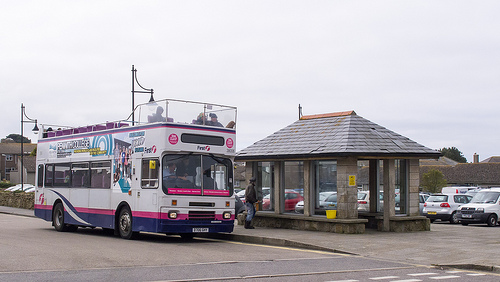Is the man to the right or to the left of the bucket? The man is to the left of the bucket. 